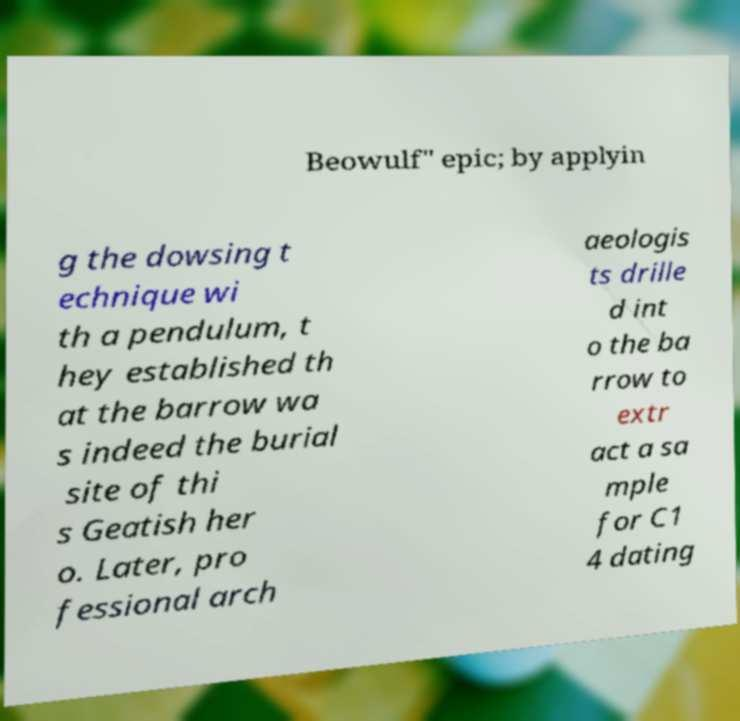Please identify and transcribe the text found in this image. Beowulf" epic; by applyin g the dowsing t echnique wi th a pendulum, t hey established th at the barrow wa s indeed the burial site of thi s Geatish her o. Later, pro fessional arch aeologis ts drille d int o the ba rrow to extr act a sa mple for C1 4 dating 